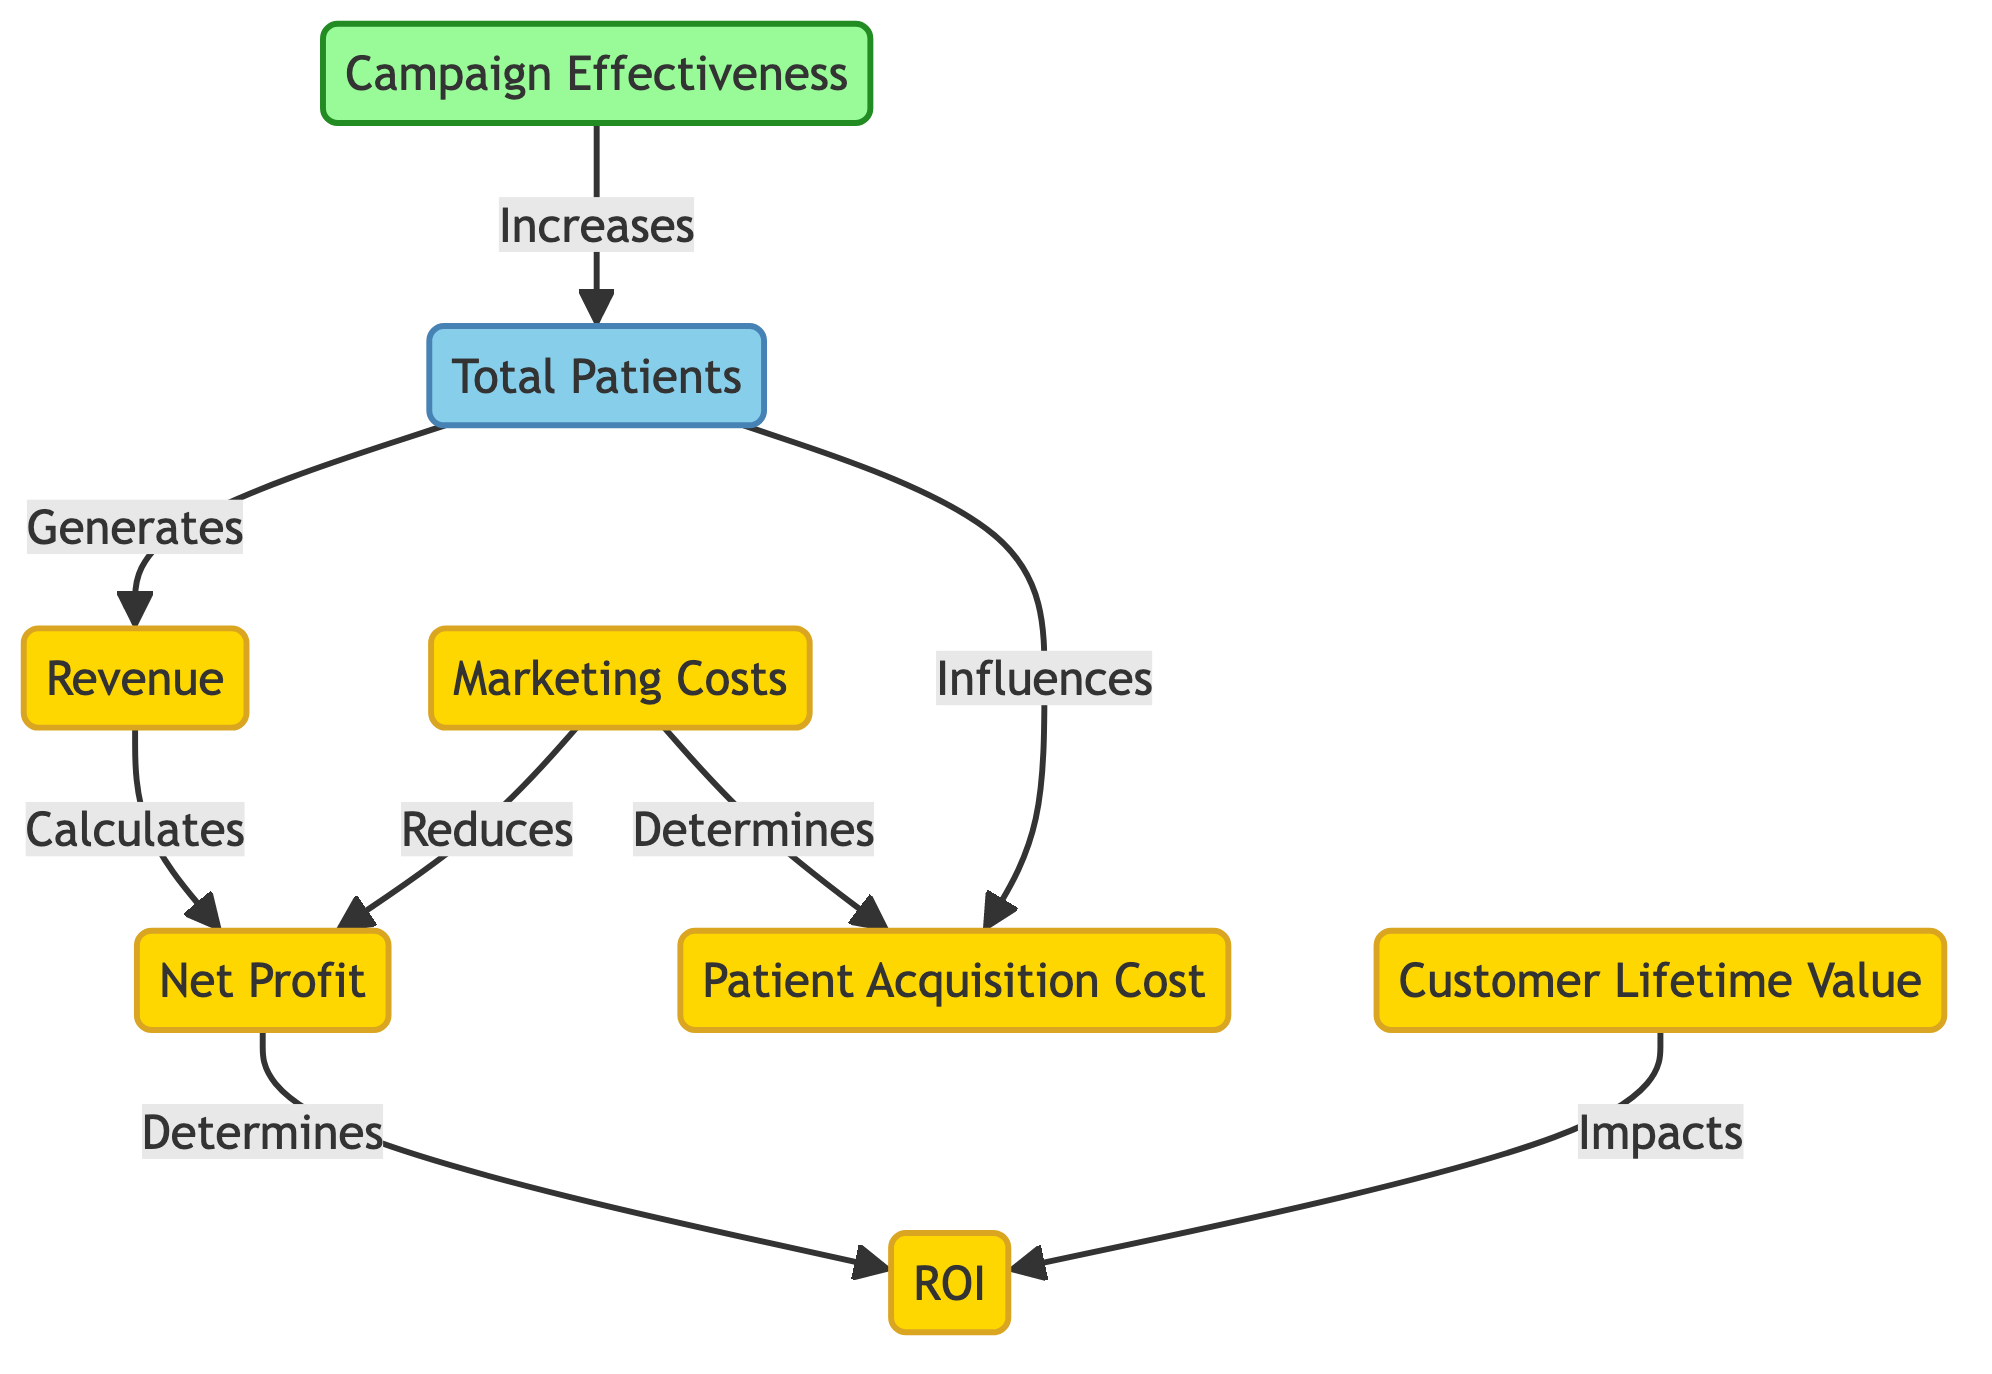What does the Total Patients node generate? The Total Patients node is connected to the Revenue node with a "Generates" relationship, indicating that the total number of patients directly generates revenue for the health services.
Answer: Revenue How do Marketing Costs affect Net Profit? The Marketing Costs node is shown to connect to the Net Profit node with a "Reduces" relationship, suggesting that higher marketing costs lead to a decrease in net profit.
Answer: Reduces What node influences Patient Acquisition Cost? The diagram shows that both Marketing Costs and Total Patients influence the Patient Acquisition Cost, indicating that these factors determine how much it costs to acquire each patient.
Answer: Total Patients How is ROI determined? The ROI node is linked to the Net Profit node with a "Determines" relationship, indicating that the return on investment is calculated based on the net profit generated.
Answer: Net Profit What effect does Campaign Effectiveness have on Total Patients? According to the diagram, Campaign Effectiveness has a direct connection to Total Patients with an "Increases" relationship, meaning that more effective marketing campaigns are expected to lead to a higher number of patients.
Answer: Increases What relationship exists between Customer Lifetime Value and ROI? The diagram shows that Customer Lifetime Value impacts the ROI node, suggesting that the lifetime value of customers has a significant effect on the calculation of return on investment.
Answer: Impacts How is Patient Acquisition Cost determined? The diagram indicates that Patient Acquisition Cost is determined by the combination of Marketing Costs and Total Patients, meaning that these factors together establish the cost required to attract a patient.
Answer: Determines What type of diagram is this? The diagram labeled is a flowchart, designed to depict relationships and processes associated with the ROI analysis of health services marketing campaigns.
Answer: Flowchart How many financial nodes are present in the diagram? By counting the nodes classified with the "financial" style, we can identify that there are five financial nodes: Revenue, Marketing Costs, Net Profit, Patient Acquisition Cost, and Customer Lifetime Value.
Answer: Five 